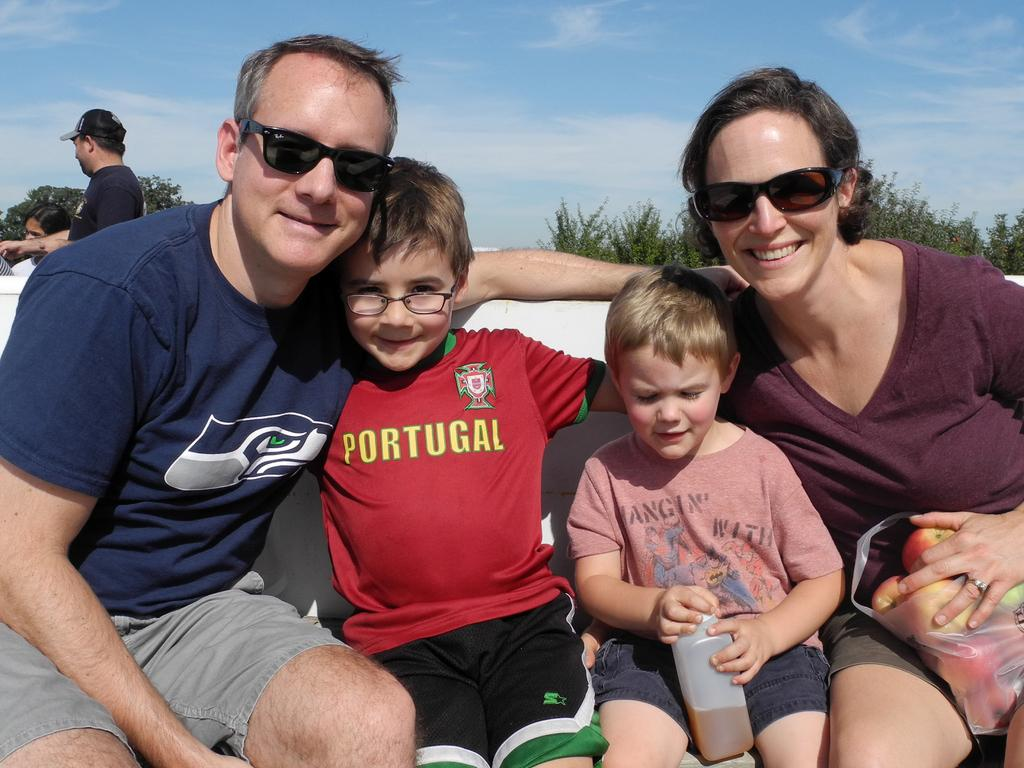How many people are sitting in the image? There are four persons sitting in the image. What else can be seen in the image besides the people sitting? There are some objects and people standing in the image. What is visible in the background of the image? There are trees and the sky visible in the background of the image. What type of yoke is being used by the people in the image? There is no yoke present in the image. Can you tell me how many lamps are visible in the image? There is no lamp present in the image. 